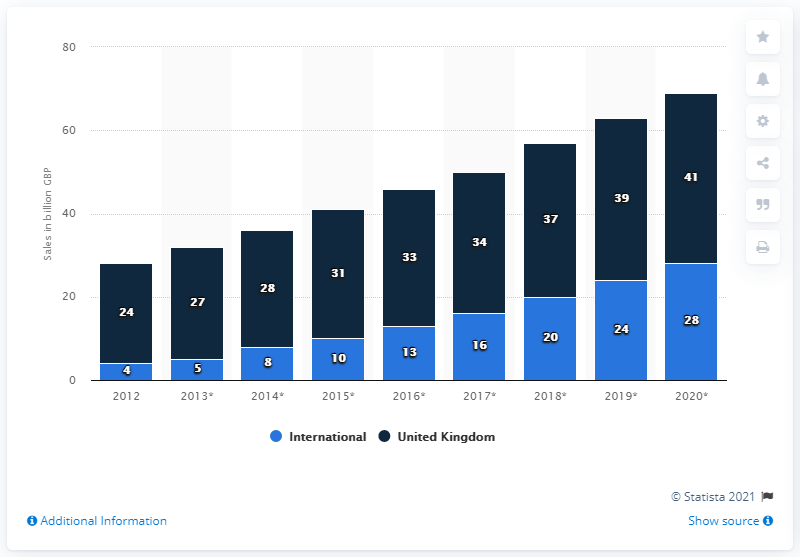Specify some key components in this picture. In 2012, the e-commerce sales revenue of retailers in the UK was measured. 